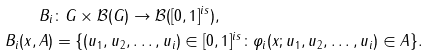<formula> <loc_0><loc_0><loc_500><loc_500>B _ { i } & \colon G \times \mathcal { B } ( G ) \to \mathcal { B } ( [ 0 , 1 ] ^ { i s } ) , \\ B _ { i } ( x , A ) & = \{ ( u _ { 1 } , u _ { 2 } , \dots , u _ { i } ) \in [ 0 , 1 ] ^ { i s } \colon \varphi _ { i } ( x ; u _ { 1 } , u _ { 2 } , \dots , u _ { i } ) \in A \} .</formula> 